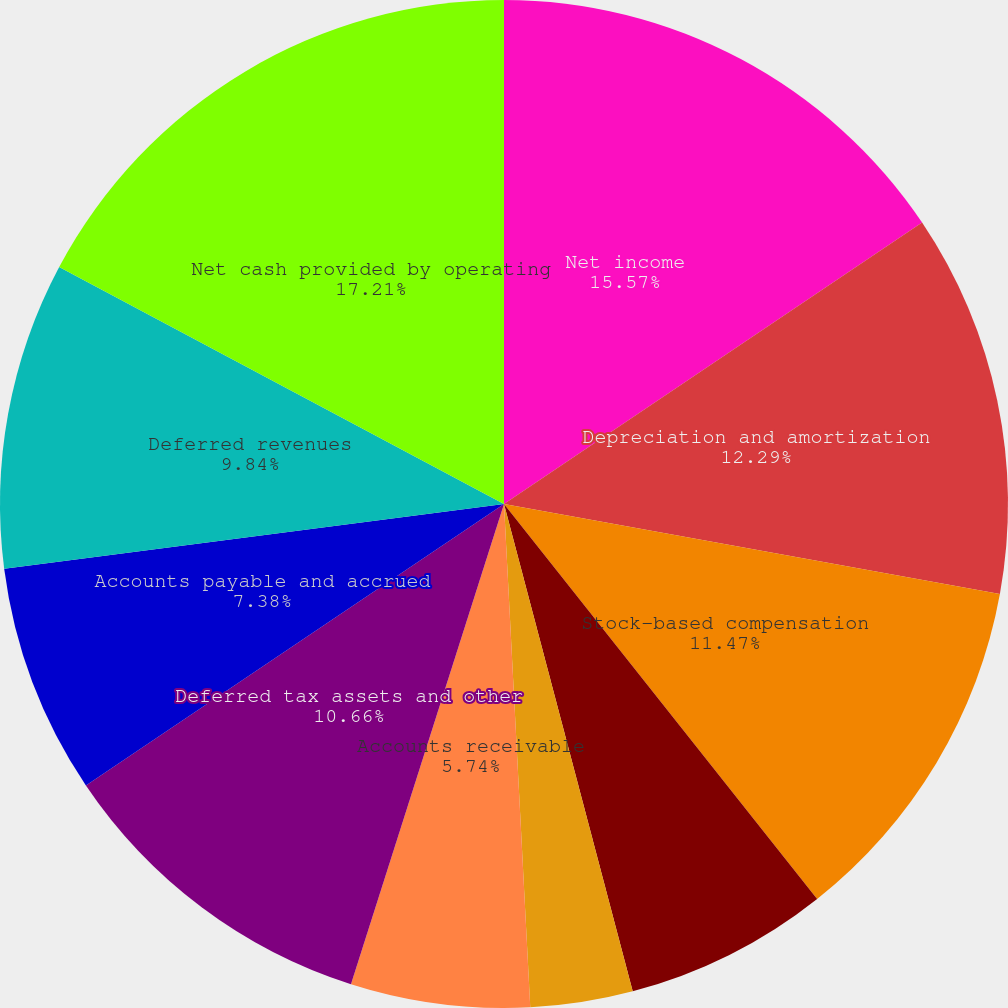Convert chart. <chart><loc_0><loc_0><loc_500><loc_500><pie_chart><fcel>Net income<fcel>Depreciation and amortization<fcel>Stock-based compensation<fcel>Excess tax benefit associated<fcel>Other net<fcel>Accounts receivable<fcel>Deferred tax assets and other<fcel>Accounts payable and accrued<fcel>Deferred revenues<fcel>Net cash provided by operating<nl><fcel>15.57%<fcel>12.29%<fcel>11.47%<fcel>6.56%<fcel>3.28%<fcel>5.74%<fcel>10.66%<fcel>7.38%<fcel>9.84%<fcel>17.21%<nl></chart> 